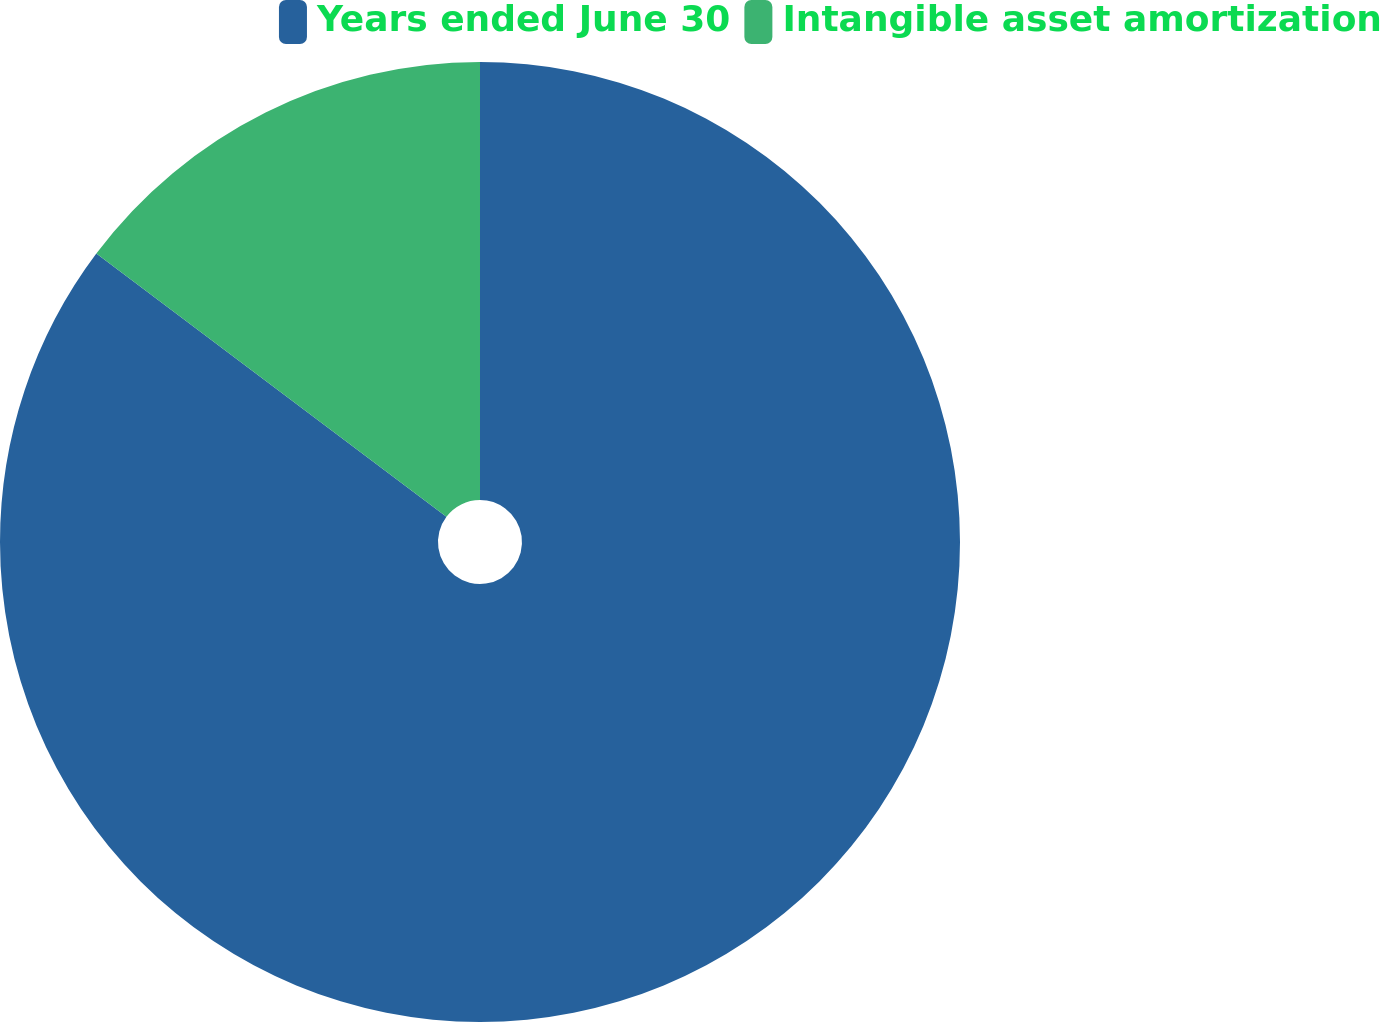<chart> <loc_0><loc_0><loc_500><loc_500><pie_chart><fcel>Years ended June 30<fcel>Intangible asset amortization<nl><fcel>85.26%<fcel>14.74%<nl></chart> 